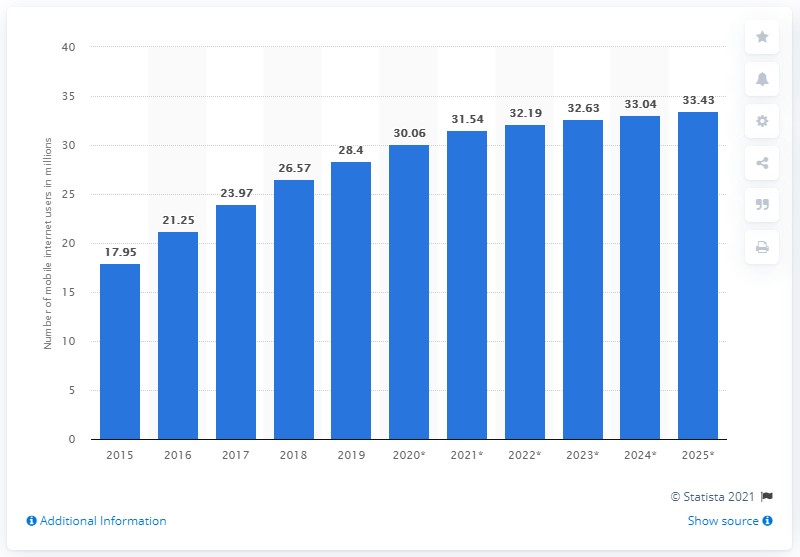Outline some significant characteristics in this image. In 2019, it was estimated that 28.4 people in Malaysia used the internet through their mobile devices. By 2025, it is projected that there will be approximately 33.43 million mobile internet users in Malaysia. 